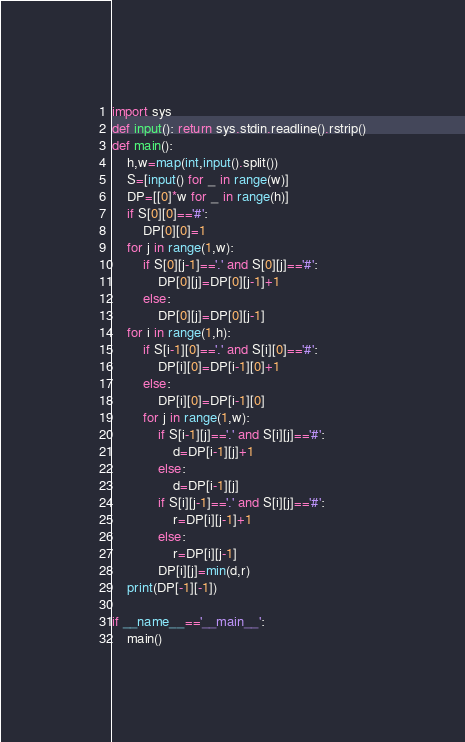Convert code to text. <code><loc_0><loc_0><loc_500><loc_500><_Python_>import sys
def input(): return sys.stdin.readline().rstrip()
def main():
    h,w=map(int,input().split())
    S=[input() for _ in range(w)]
    DP=[[0]*w for _ in range(h)]
    if S[0][0]=='#':
        DP[0][0]=1
    for j in range(1,w):
        if S[0][j-1]=='.' and S[0][j]=='#':
            DP[0][j]=DP[0][j-1]+1
        else:
            DP[0][j]=DP[0][j-1]
    for i in range(1,h):
        if S[i-1][0]=='.' and S[i][0]=='#':
            DP[i][0]=DP[i-1][0]+1
        else:
            DP[i][0]=DP[i-1][0]
        for j in range(1,w):
            if S[i-1][j]=='.' and S[i][j]=='#':
                d=DP[i-1][j]+1
            else:
                d=DP[i-1][j]
            if S[i][j-1]=='.' and S[i][j]=='#':
                r=DP[i][j-1]+1
            else:
                r=DP[i][j-1]
            DP[i][j]=min(d,r)
    print(DP[-1][-1])

if __name__=='__main__':
    main()</code> 